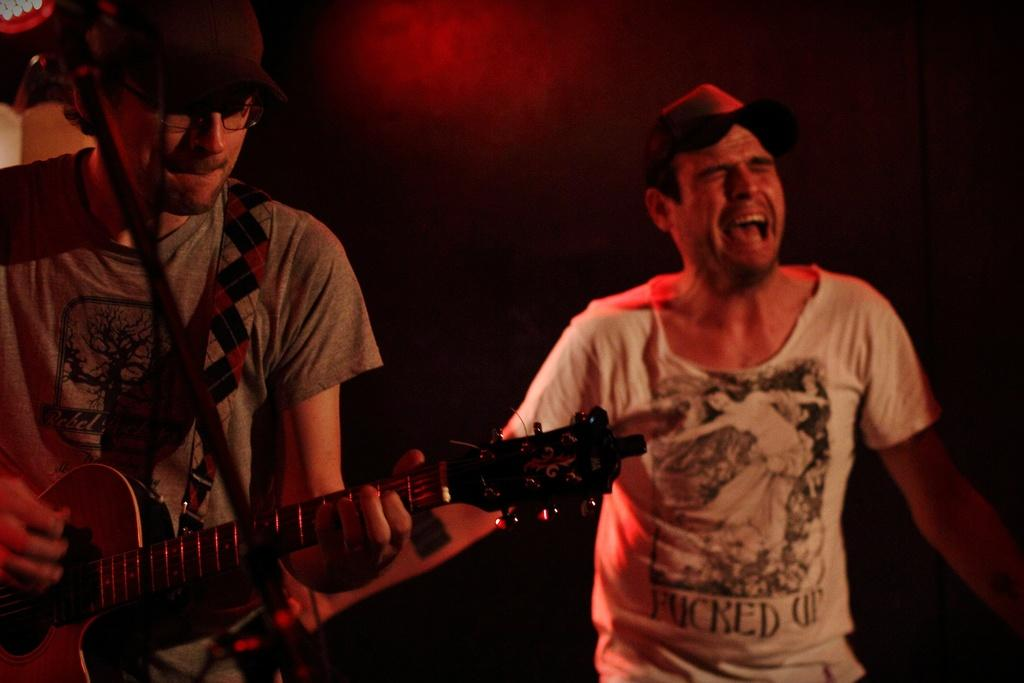What is the man in the image holding? The man in the image is holding a guitar. Can you describe the position of the man holding the guitar? The man holding the guitar is standing beside another man. What can be seen on the head of the other man? The other man is wearing a cap. How many fans can be seen in the background of the image? There are no fans visible in the background of the image. 